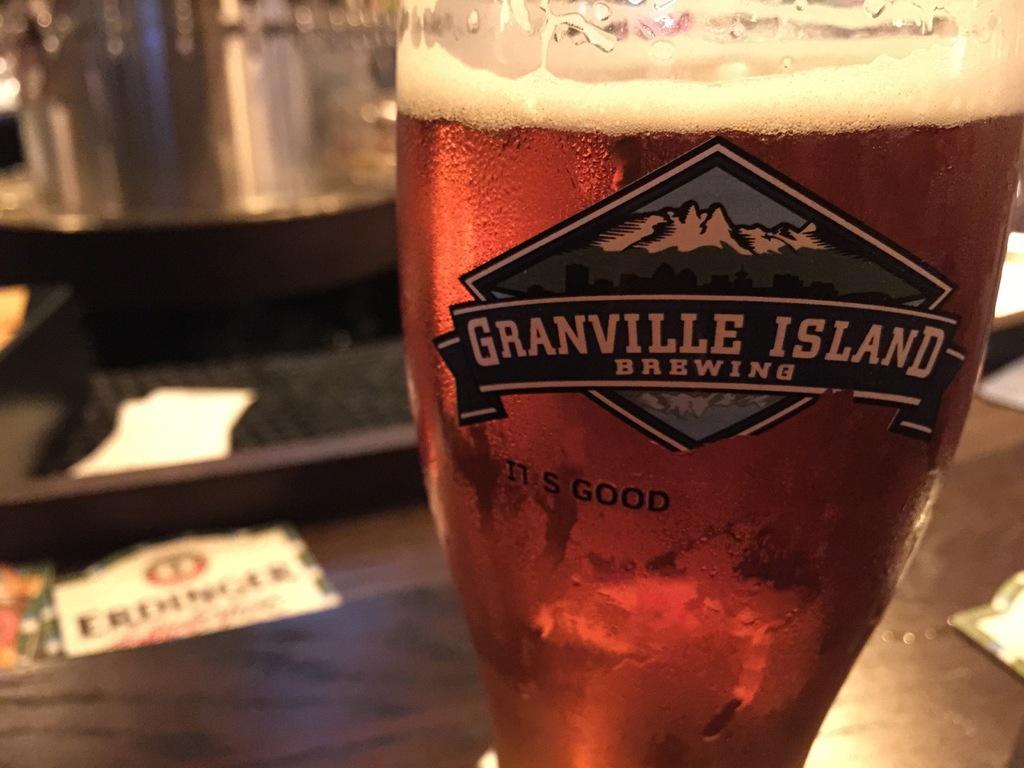What type of beverage is this?
Provide a succinct answer. Beer. 